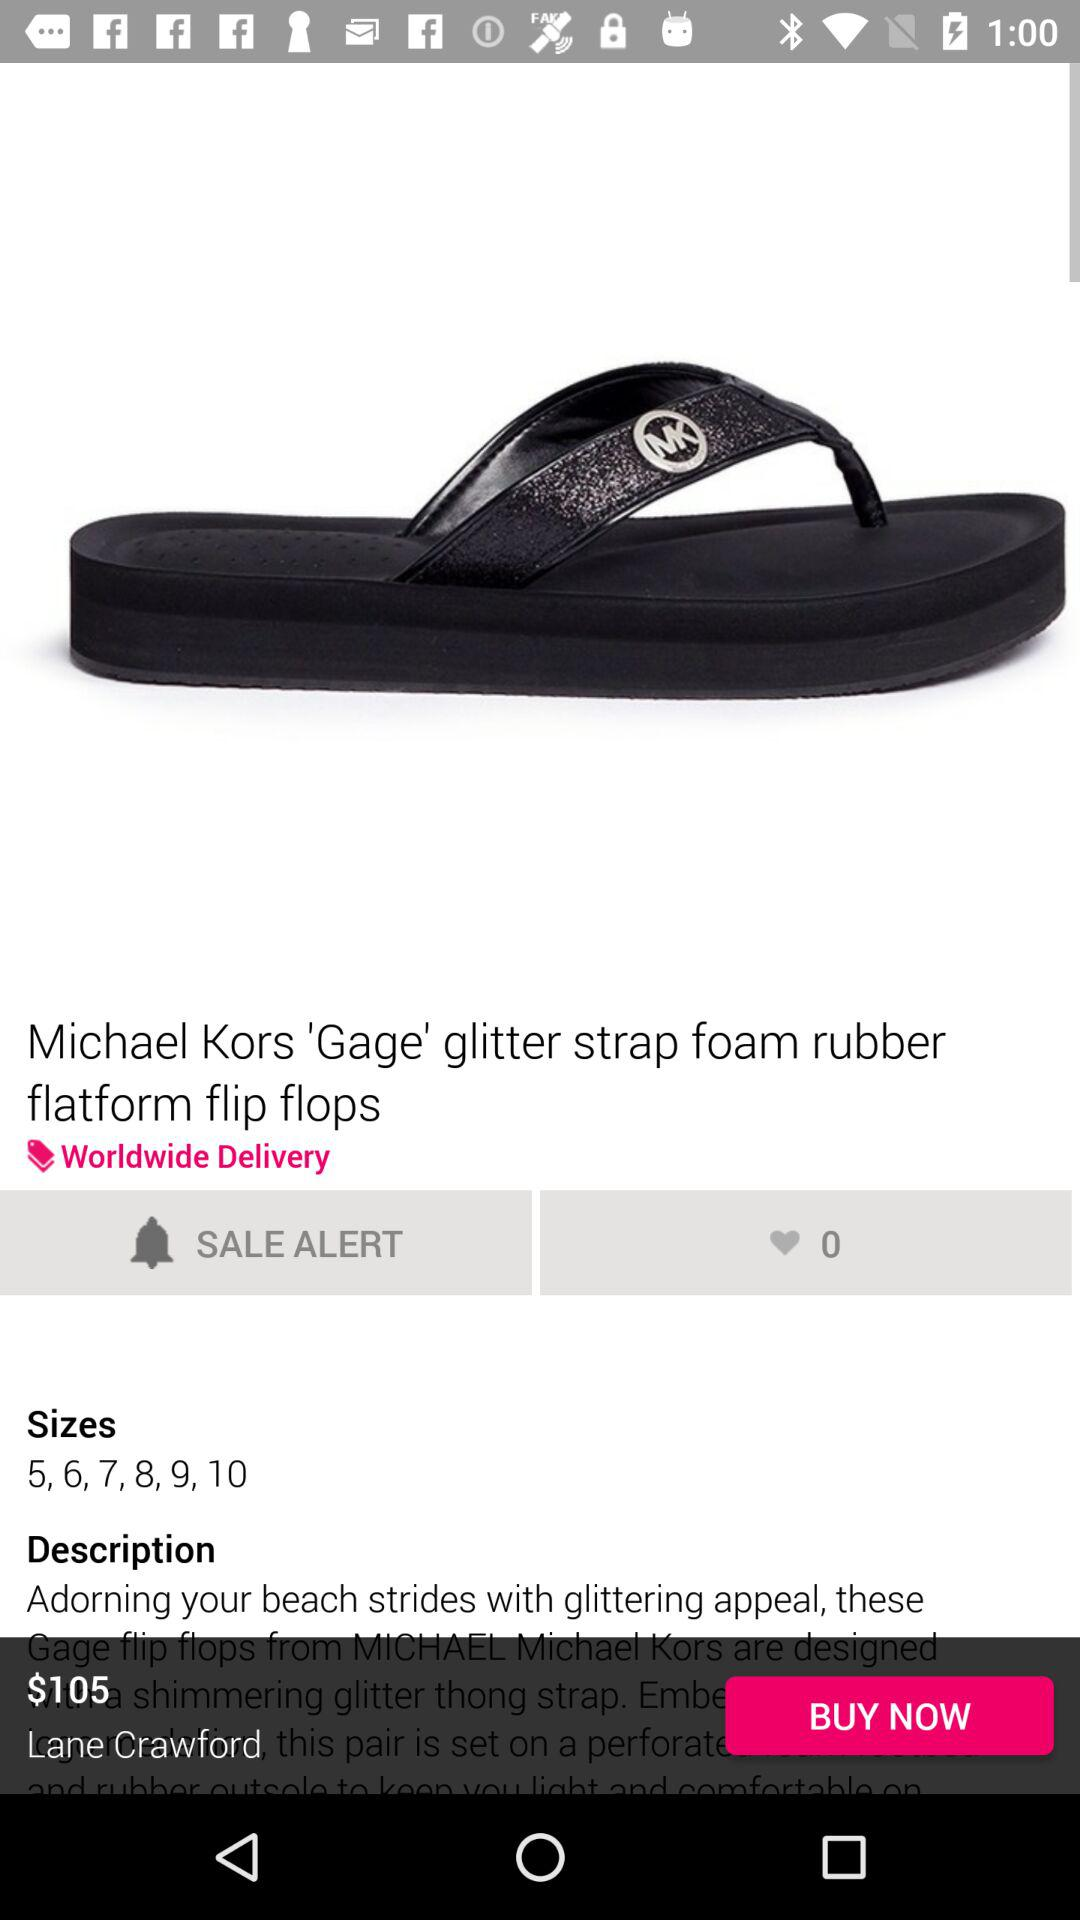What is the availability of the delivery? The availability is worldwide. 